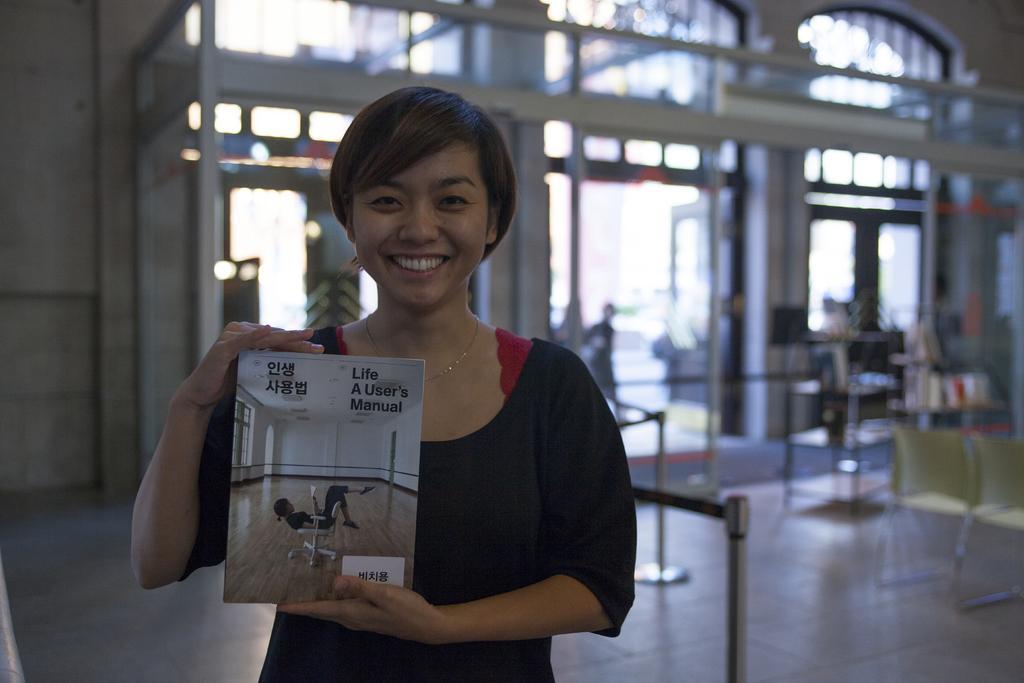In one or two sentences, can you explain what this image depicts? In the image we can see a woman standing, wearing clothes, neck chain and she is smiling. She is holding a book in her hand. Here we can see the door, floor, chairs and the background is blurred.  